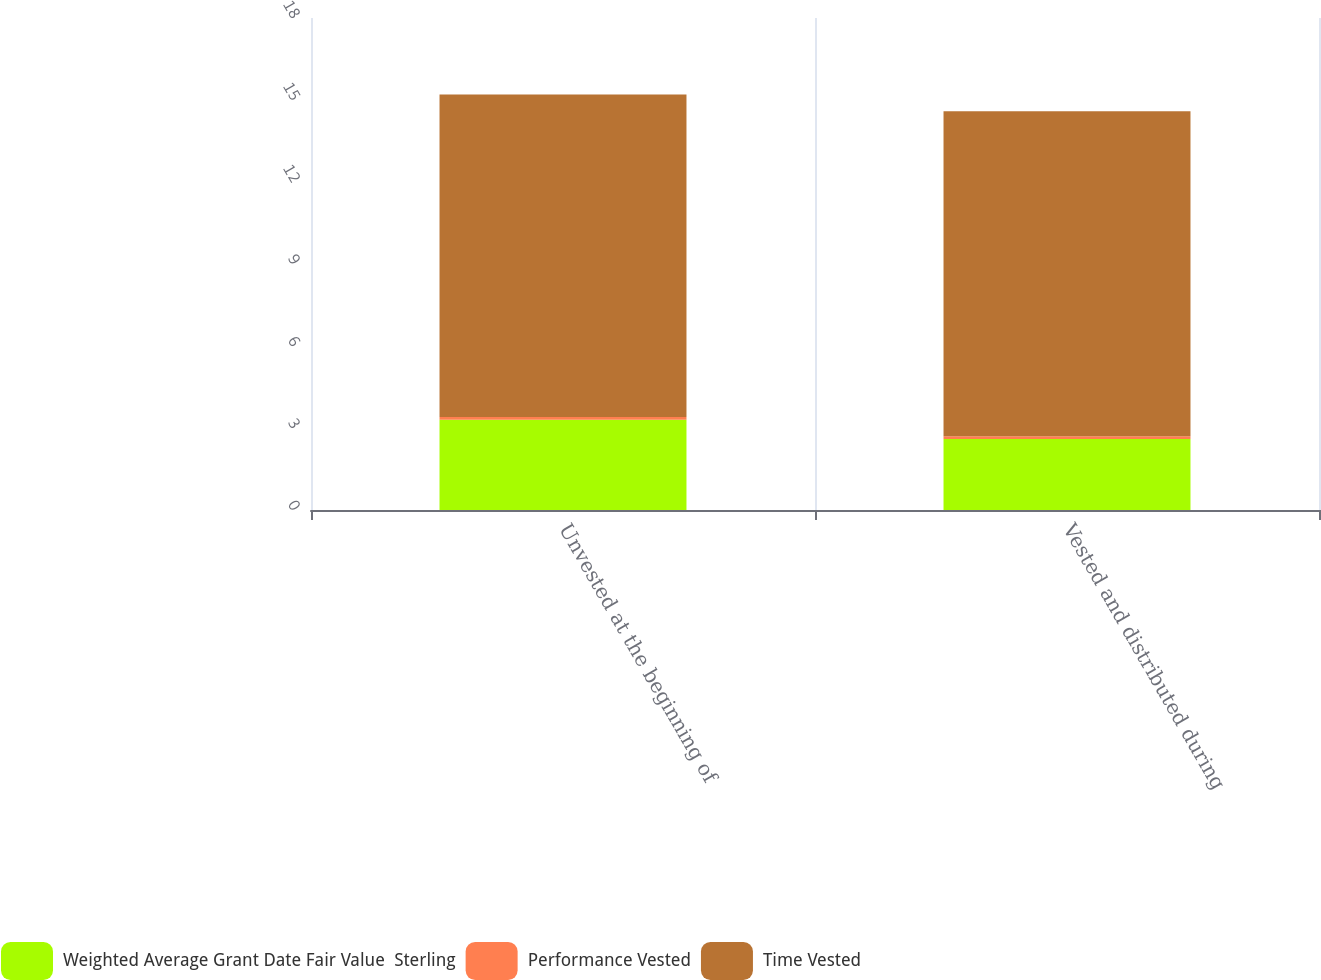Convert chart. <chart><loc_0><loc_0><loc_500><loc_500><stacked_bar_chart><ecel><fcel>Unvested at the beginning of<fcel>Vested and distributed during<nl><fcel>Weighted Average Grant Date Fair Value  Sterling<fcel>3.3<fcel>2.6<nl><fcel>Performance Vested<fcel>0.1<fcel>0.1<nl><fcel>Time Vested<fcel>11.8<fcel>11.89<nl></chart> 